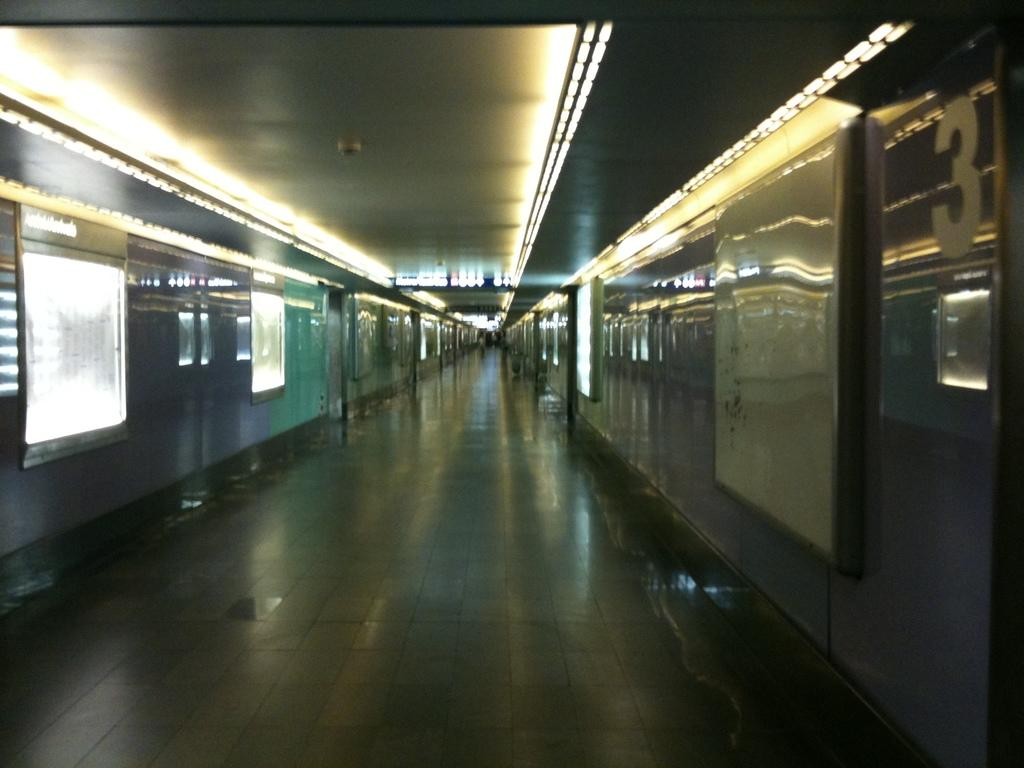What is the main structure visible in the image? There is a platform in the image. What can be seen on the platform? There are trains on either side of the platform. What feature do the trains have? The trains have glass windows. What is visible on the ceiling of the platform? There are lights visible on the ceiling of the platform. What type of substance is leaking from the train on the left side of the platform? There is no indication of any substance leaking from the train in the image. 